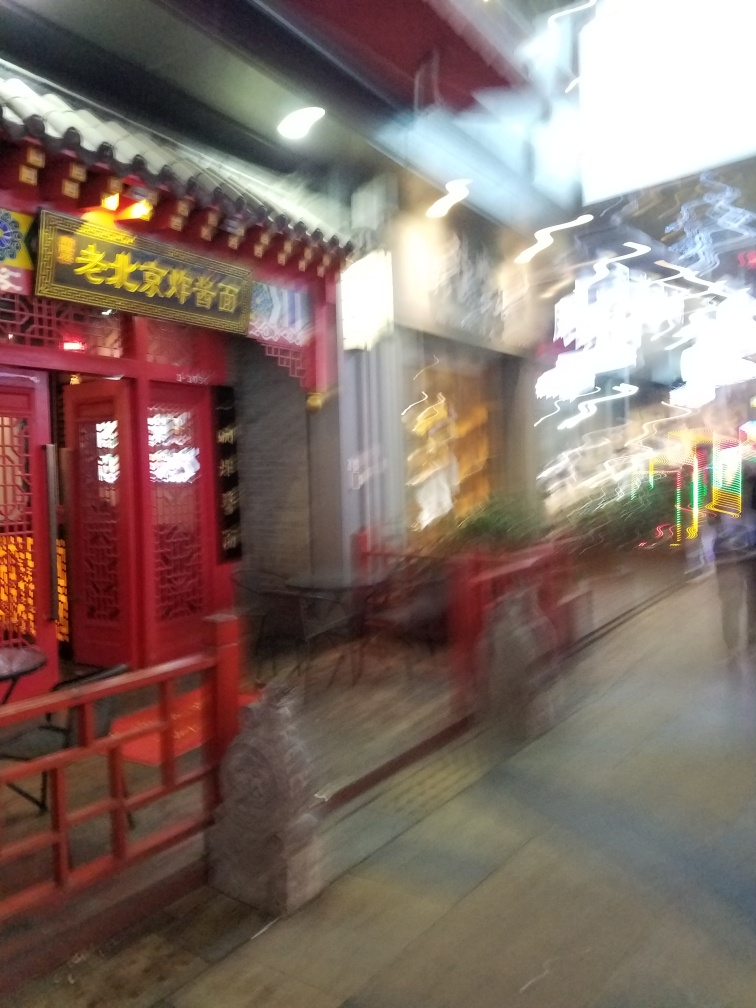Could you describe the elements of the door that might indicate this is a historical or culturally significant location? The door in the image features characteristic chǐmén or 'spirit walls', which are intended to protect the home from evil spirits, and intricate wood lattices that suggest a thoughtful aesthetic consistent with historical Chinese architecture. Red is a particularly auspicious color in Chinese culture, often tied to good fortune and joy, which could reveal the place's cultural significance. 